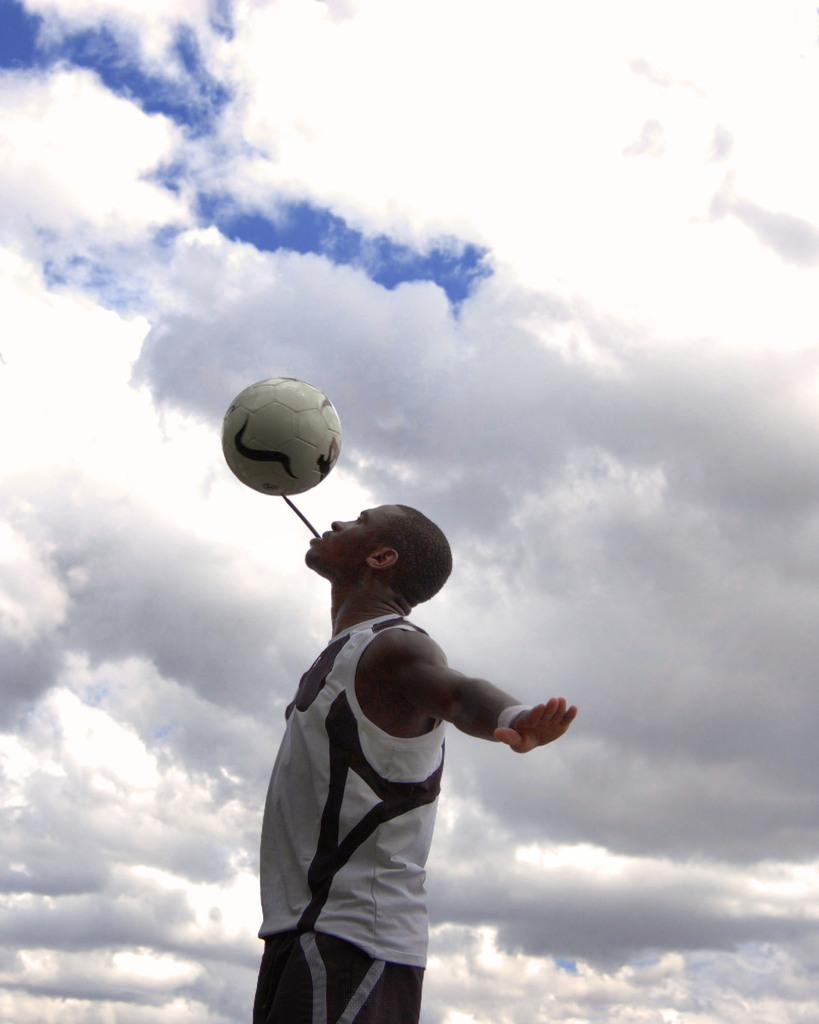What can be seen in the background of the image? There is a blue sky with clouds in the background. Who is present in the image? There is a man in the image. What is the man wearing? The man is wearing a white shirt with a cloud pattern. What accessory is the man wearing on his wrist? The man is wearing a wristband. What object is the man holding? The man is holding a ball. What unusual item is the man holding in his mouth? The man has a stick in his mouth. What type of engine can be seen in the image? There is no engine present in the image. Is there a plane visible in the image? No, there is no plane visible in the image. What type of lettuce is the man eating in the image? There is no lettuce present in the image; the man is holding a ball and has a stick in his mouth. 